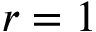Convert formula to latex. <formula><loc_0><loc_0><loc_500><loc_500>r = 1</formula> 